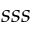<formula> <loc_0><loc_0><loc_500><loc_500>s s s</formula> 